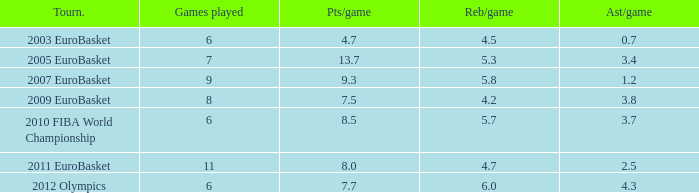How many assists per game in the tournament 2010 fiba world championship? 3.7. 